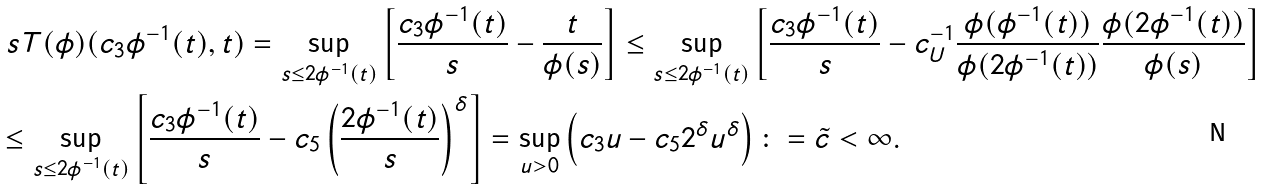Convert formula to latex. <formula><loc_0><loc_0><loc_500><loc_500>& \ s T ( \phi ) ( c _ { 3 } \phi ^ { - 1 } ( t ) , t ) = \sup _ { s \leq 2 \phi ^ { - 1 } ( t ) } \left [ \frac { c _ { 3 } \phi ^ { - 1 } ( t ) } { s } - \frac { t } { \phi ( s ) } \right ] \leq \sup _ { s \leq 2 \phi ^ { - 1 } ( t ) } \left [ \frac { c _ { 3 } \phi ^ { - 1 } ( t ) } { s } - c _ { U } ^ { - 1 } \frac { \phi ( \phi ^ { - 1 } ( t ) ) } { \phi ( 2 \phi ^ { - 1 } ( t ) ) } \frac { \phi ( 2 \phi ^ { - 1 } ( t ) ) } { \phi ( s ) } \right ] \\ & \leq \sup _ { s \leq 2 \phi ^ { - 1 } ( t ) } \left [ \frac { c _ { 3 } \phi ^ { - 1 } ( t ) } { s } - c _ { 5 } \left ( \frac { 2 \phi ^ { - 1 } ( t ) } { s } \right ) ^ { \delta } \right ] = \sup _ { u > 0 } \left ( c _ { 3 } u - c _ { 5 } 2 ^ { \delta } u ^ { \delta } \right ) \colon = \tilde { c } < \infty .</formula> 